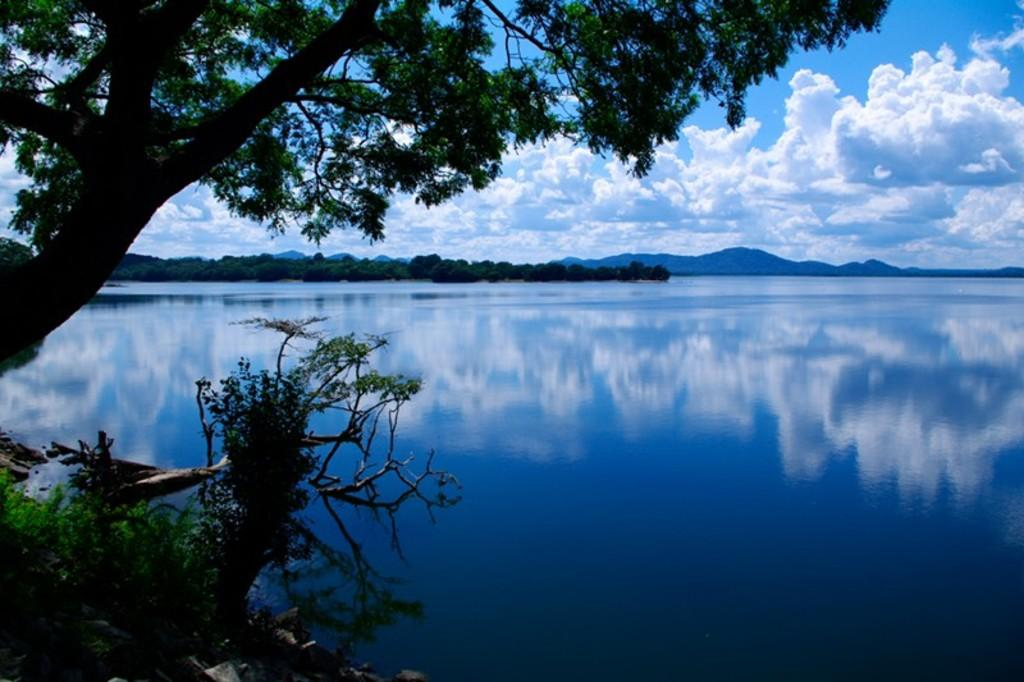What is the primary element visible in the image? There is water in the image. What type of vegetation can be seen in the image? There are trees in the image. How would you describe the sky in the image? The sky is cloudy in the image. What is the rate of the cherries falling from the trees in the image? There are no cherries present in the image, so it is not possible to determine a rate of falling. 